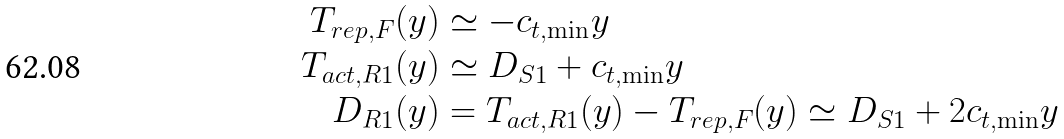Convert formula to latex. <formula><loc_0><loc_0><loc_500><loc_500>T _ { r e p , F } ( y ) & \simeq - c _ { t , \min } y \\ T _ { a c t , R 1 } ( y ) & \simeq D _ { S 1 } + c _ { t , \min } y \\ D _ { R 1 } ( y ) & = T _ { a c t , R 1 } ( y ) - T _ { r e p , F } ( y ) \simeq D _ { S 1 } + 2 c _ { t , \min } y</formula> 